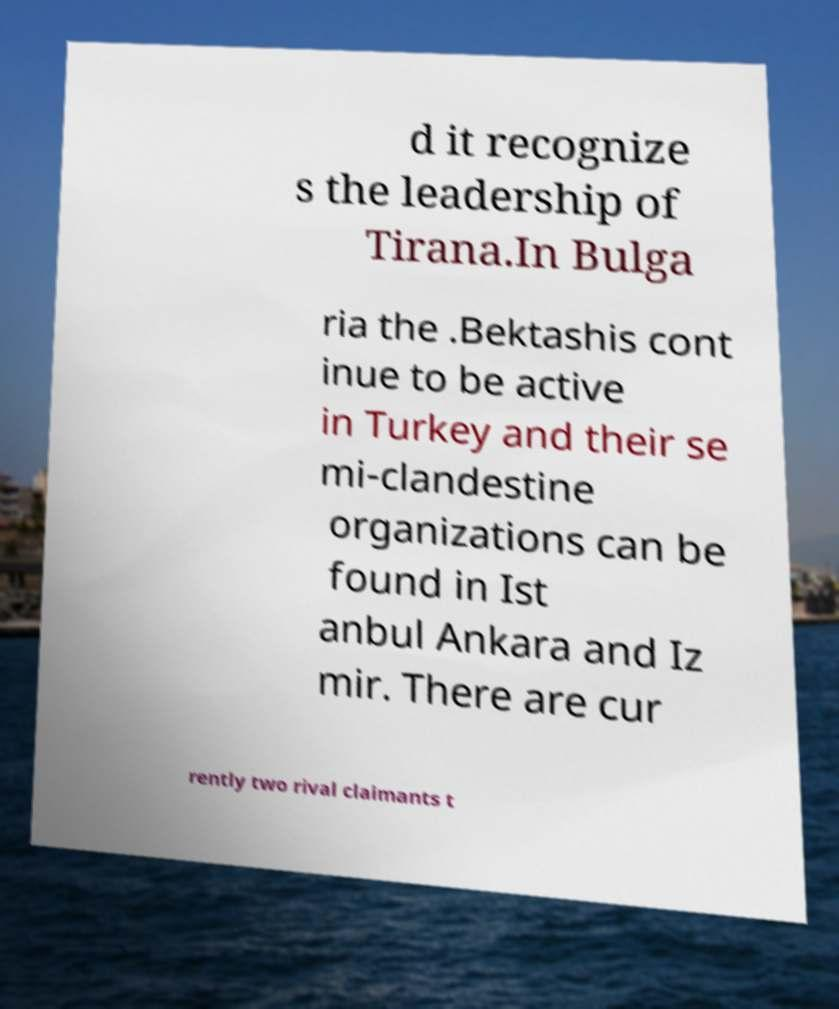Can you accurately transcribe the text from the provided image for me? d it recognize s the leadership of Tirana.In Bulga ria the .Bektashis cont inue to be active in Turkey and their se mi-clandestine organizations can be found in Ist anbul Ankara and Iz mir. There are cur rently two rival claimants t 